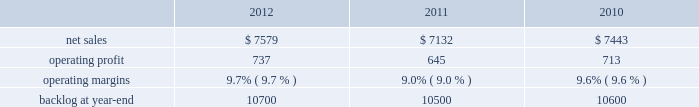2011 compared to 2010 mfc 2019s net sales for 2011 increased $ 533 million , or 8% ( 8 % ) , compared to 2010 .
The increase was attributable to higher volume of about $ 420 million on air and missile defense programs ( primarily pac-3 and thaad ) ; and about $ 245 million from fire control systems programs primarily related to the sof clss program , which began late in the third quarter of 2010 .
Partially offsetting these increases were lower net sales due to decreased volume of approximately $ 75 million primarily from various services programs and approximately $ 20 million from tactical missile programs ( primarily mlrs and jassm ) .
Mfc 2019s operating profit for 2011 increased $ 96 million , or 10% ( 10 % ) , compared to 2010 .
The increase was attributable to higher operating profit of about $ 60 million for air and missile defense programs ( primarily pac-3 and thaad ) as a result of increased volume and retirement of risks ; and approximately $ 25 million for various services programs .
Adjustments not related to volume , including net profit rate adjustments described above , were approximately $ 35 million higher in 2011 compared to 2010 .
Backlog backlog increased in 2012 compared to 2011 mainly due to increased orders and lower sales on fire control systems programs ( primarily lantirn ae and sniper ae ) and on various services programs , partially offset by lower orders and higher sales volume on tactical missiles programs .
Backlog increased in 2011 compared to 2010 primarily due to increased orders on air and missile defense programs ( primarily thaad ) .
Trends we expect mfc 2019s net sales for 2013 will be comparable with 2012 .
We expect low double digit percentage growth in air and missile defense programs , offset by an expected decline in volume on logistics services programs .
Operating profit and margin are expected to be comparable with 2012 results .
Mission systems and training our mst business segment provides surface ship and submarine combat systems ; sea and land-based missile defense systems ; radar systems ; mission systems and sensors for rotary and fixed-wing aircraft ; littoral combat ships ; simulation and training services ; unmanned technologies and platforms ; ship systems integration ; and military and commercial training systems .
Mst 2019s major programs include aegis , mk-41 vertical launching system ( vls ) , tpq-53 radar system , mh-60 , lcs , and ptds .
Mst 2019s operating results included the following ( in millions ) : .
2012 compared to 2011 mst 2019s net sales for 2012 increased $ 447 million , or 6% ( 6 % ) , compared to 2011 .
The increase in net sales for 2012 was attributable to higher volume and risk retirements of approximately $ 395 million from ship and aviation system programs ( primarily ptds ; lcs ; vls ; and mh-60 ) ; about $ 115 million for training and logistics solutions programs primarily due to net sales from sim industries , which was acquired in the fourth quarter of 2011 ; and approximately $ 30 million as a result of increased volume on integrated warfare systems and sensors programs ( primarily aegis ) .
Partially offsetting the increases were lower net sales of approximately $ 70 million from undersea systems programs due to lower volume on an international combat system program and towed array systems ; and about $ 25 million due to lower volume on various other programs .
Mst 2019s operating profit for 2012 increased $ 92 million , or 14% ( 14 % ) , compared to 2011 .
The increase was attributable to higher operating profit of approximately $ 175 million from ship and aviation system programs , which reflects higher volume and risk retirements on certain programs ( primarily vls ; ptds ; mh-60 ; and lcs ) and reserves of about $ 55 million for contract cost matters on ship and aviation system programs recorded in the fourth quarter of 2011 ( including the terminated presidential helicopter program ) .
Partially offsetting the increase was lower operating profit of approximately $ 40 million from undersea systems programs due to reduced profit booking rates on certain programs and lower volume on an international combat system program and towed array systems ; and about $ 40 million due to lower volume on various other programs .
Adjustments not related to volume , including net profit booking rate adjustments and other matters described above , were approximately $ 150 million higher for 2012 compared to 2011. .
What is the growth rate in operating profit for mst in 2012? 
Computations: ((737 - 645) / 645)
Answer: 0.14264. 2011 compared to 2010 mfc 2019s net sales for 2011 increased $ 533 million , or 8% ( 8 % ) , compared to 2010 .
The increase was attributable to higher volume of about $ 420 million on air and missile defense programs ( primarily pac-3 and thaad ) ; and about $ 245 million from fire control systems programs primarily related to the sof clss program , which began late in the third quarter of 2010 .
Partially offsetting these increases were lower net sales due to decreased volume of approximately $ 75 million primarily from various services programs and approximately $ 20 million from tactical missile programs ( primarily mlrs and jassm ) .
Mfc 2019s operating profit for 2011 increased $ 96 million , or 10% ( 10 % ) , compared to 2010 .
The increase was attributable to higher operating profit of about $ 60 million for air and missile defense programs ( primarily pac-3 and thaad ) as a result of increased volume and retirement of risks ; and approximately $ 25 million for various services programs .
Adjustments not related to volume , including net profit rate adjustments described above , were approximately $ 35 million higher in 2011 compared to 2010 .
Backlog backlog increased in 2012 compared to 2011 mainly due to increased orders and lower sales on fire control systems programs ( primarily lantirn ae and sniper ae ) and on various services programs , partially offset by lower orders and higher sales volume on tactical missiles programs .
Backlog increased in 2011 compared to 2010 primarily due to increased orders on air and missile defense programs ( primarily thaad ) .
Trends we expect mfc 2019s net sales for 2013 will be comparable with 2012 .
We expect low double digit percentage growth in air and missile defense programs , offset by an expected decline in volume on logistics services programs .
Operating profit and margin are expected to be comparable with 2012 results .
Mission systems and training our mst business segment provides surface ship and submarine combat systems ; sea and land-based missile defense systems ; radar systems ; mission systems and sensors for rotary and fixed-wing aircraft ; littoral combat ships ; simulation and training services ; unmanned technologies and platforms ; ship systems integration ; and military and commercial training systems .
Mst 2019s major programs include aegis , mk-41 vertical launching system ( vls ) , tpq-53 radar system , mh-60 , lcs , and ptds .
Mst 2019s operating results included the following ( in millions ) : .
2012 compared to 2011 mst 2019s net sales for 2012 increased $ 447 million , or 6% ( 6 % ) , compared to 2011 .
The increase in net sales for 2012 was attributable to higher volume and risk retirements of approximately $ 395 million from ship and aviation system programs ( primarily ptds ; lcs ; vls ; and mh-60 ) ; about $ 115 million for training and logistics solutions programs primarily due to net sales from sim industries , which was acquired in the fourth quarter of 2011 ; and approximately $ 30 million as a result of increased volume on integrated warfare systems and sensors programs ( primarily aegis ) .
Partially offsetting the increases were lower net sales of approximately $ 70 million from undersea systems programs due to lower volume on an international combat system program and towed array systems ; and about $ 25 million due to lower volume on various other programs .
Mst 2019s operating profit for 2012 increased $ 92 million , or 14% ( 14 % ) , compared to 2011 .
The increase was attributable to higher operating profit of approximately $ 175 million from ship and aviation system programs , which reflects higher volume and risk retirements on certain programs ( primarily vls ; ptds ; mh-60 ; and lcs ) and reserves of about $ 55 million for contract cost matters on ship and aviation system programs recorded in the fourth quarter of 2011 ( including the terminated presidential helicopter program ) .
Partially offsetting the increase was lower operating profit of approximately $ 40 million from undersea systems programs due to reduced profit booking rates on certain programs and lower volume on an international combat system program and towed array systems ; and about $ 40 million due to lower volume on various other programs .
Adjustments not related to volume , including net profit booking rate adjustments and other matters described above , were approximately $ 150 million higher for 2012 compared to 2011. .
What is the growth rate in operating profit for mst in 2011? 
Computations: ((645 - 713) / 713)
Answer: -0.09537. 